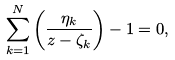Convert formula to latex. <formula><loc_0><loc_0><loc_500><loc_500>\sum _ { k = 1 } ^ { N } \left ( \frac { \eta _ { k } } { z - \zeta _ { k } } \right ) - 1 = 0 ,</formula> 